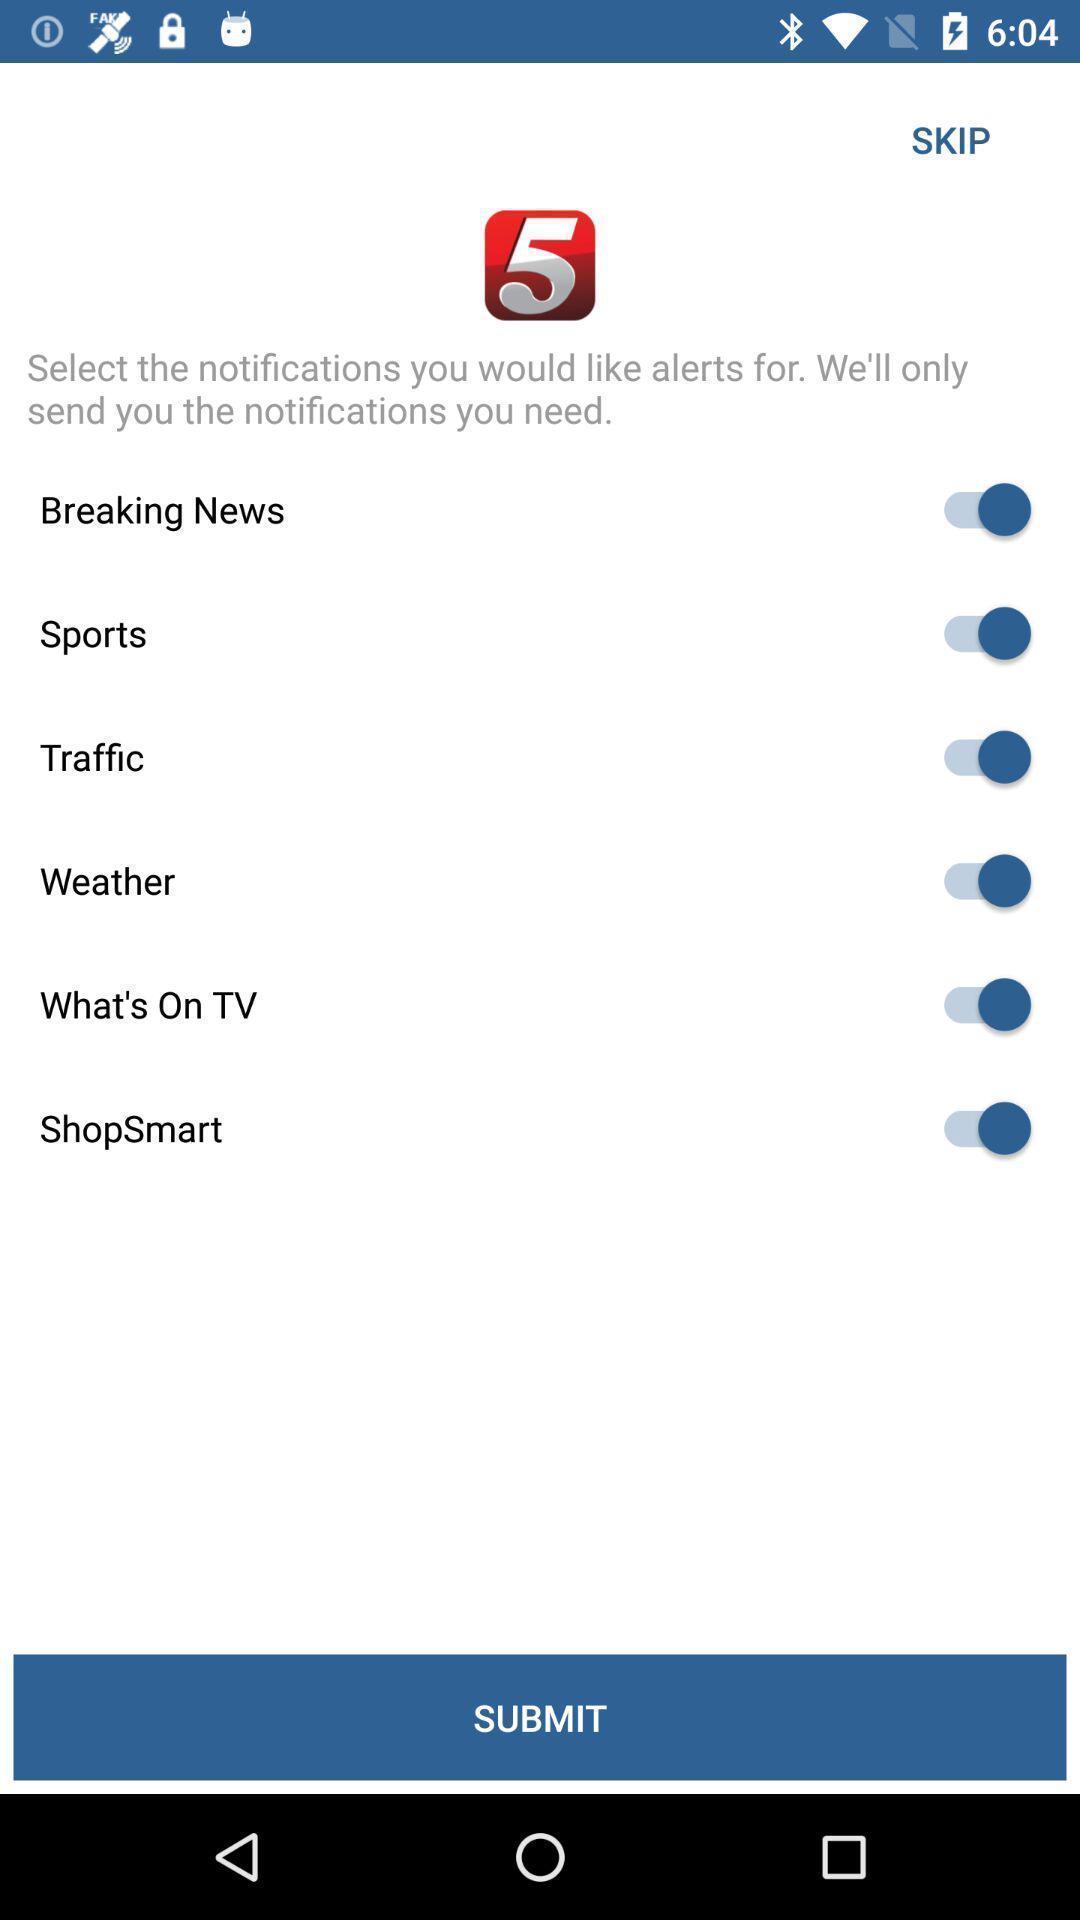Describe the content in this image. Submit page of a live news app. 